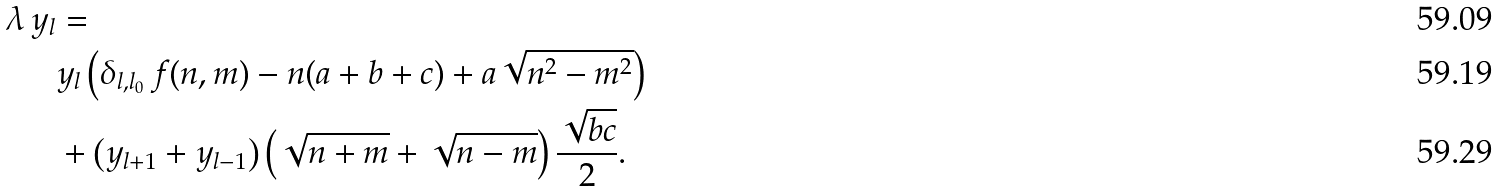Convert formula to latex. <formula><loc_0><loc_0><loc_500><loc_500>\lambda \, y _ { l } & = \\ & y _ { l } \left ( \delta _ { l , l _ { 0 } } \, f ( n , m ) - n ( a + b + c ) + a \sqrt { n ^ { 2 } - m ^ { 2 } } \right ) \\ & + \left ( y _ { l + 1 } + y _ { l - 1 } \right ) \left ( \sqrt { n + m } + \sqrt { n - m } \right ) \frac { \sqrt { b c } } { 2 } .</formula> 